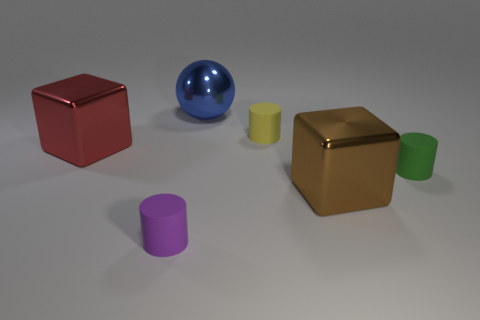How many other things are the same shape as the purple thing?
Your response must be concise. 2. Does the small cylinder left of the blue metallic sphere have the same material as the small green thing?
Your response must be concise. Yes. Are there the same number of green things that are in front of the big brown metallic object and red blocks that are behind the large red metal cube?
Provide a succinct answer. Yes. There is a blue object behind the tiny purple thing; what size is it?
Provide a short and direct response. Large. Is there a purple cylinder that has the same material as the red thing?
Give a very brief answer. No. There is a big object in front of the small green cylinder; is it the same color as the big sphere?
Give a very brief answer. No. Is the number of blue metal objects in front of the brown metallic thing the same as the number of cyan metallic cubes?
Your answer should be compact. Yes. Does the blue metallic thing have the same size as the green matte cylinder?
Your answer should be very brief. No. There is a matte object behind the large metallic block that is to the left of the purple cylinder; what size is it?
Offer a very short reply. Small. There is a object that is both left of the big brown shiny thing and in front of the small green object; what size is it?
Offer a terse response. Small. 